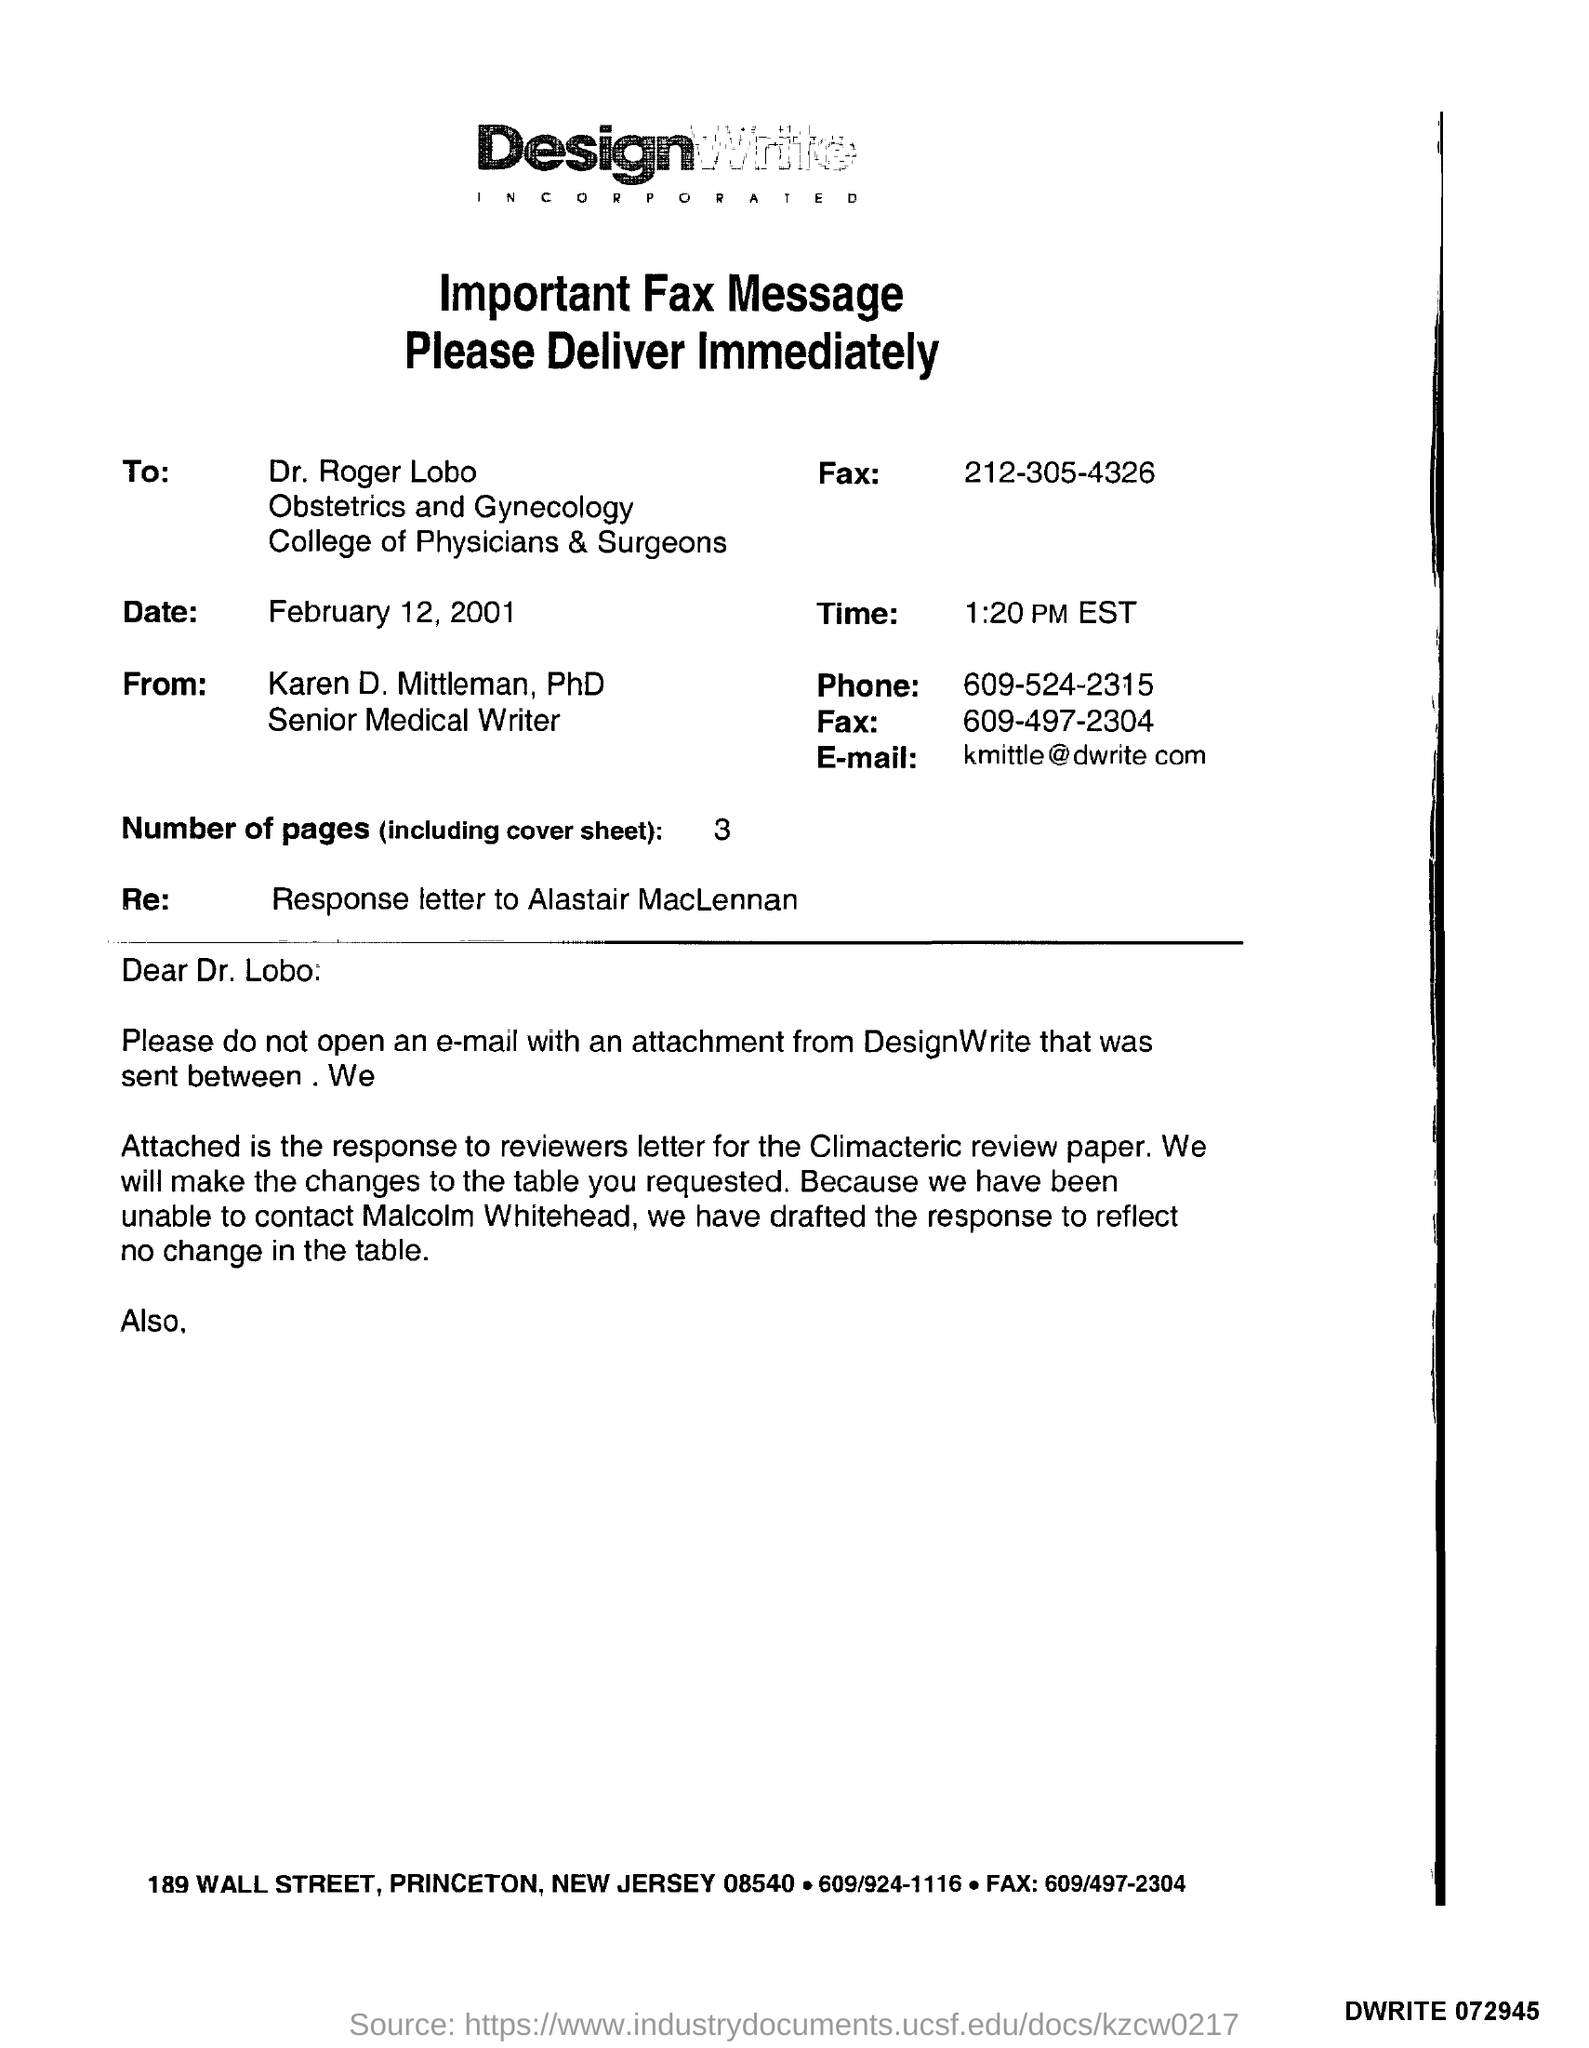What is the time?
Make the answer very short. 1:20 PM EST. What is the salutation of this letter?
Make the answer very short. Dear Dr. Lobo. What is the number of pages?
Your response must be concise. 3. What is the E- mail address?
Provide a succinct answer. Kmittle@dwrite.com. 